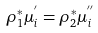<formula> <loc_0><loc_0><loc_500><loc_500>\label l { e q \colon p u l l - b a c k } \rho _ { 1 } ^ { * } \mu _ { i } ^ { ^ { \prime } } = \rho _ { 2 } ^ { * } \mu _ { i } ^ { ^ { \prime \prime } }</formula> 